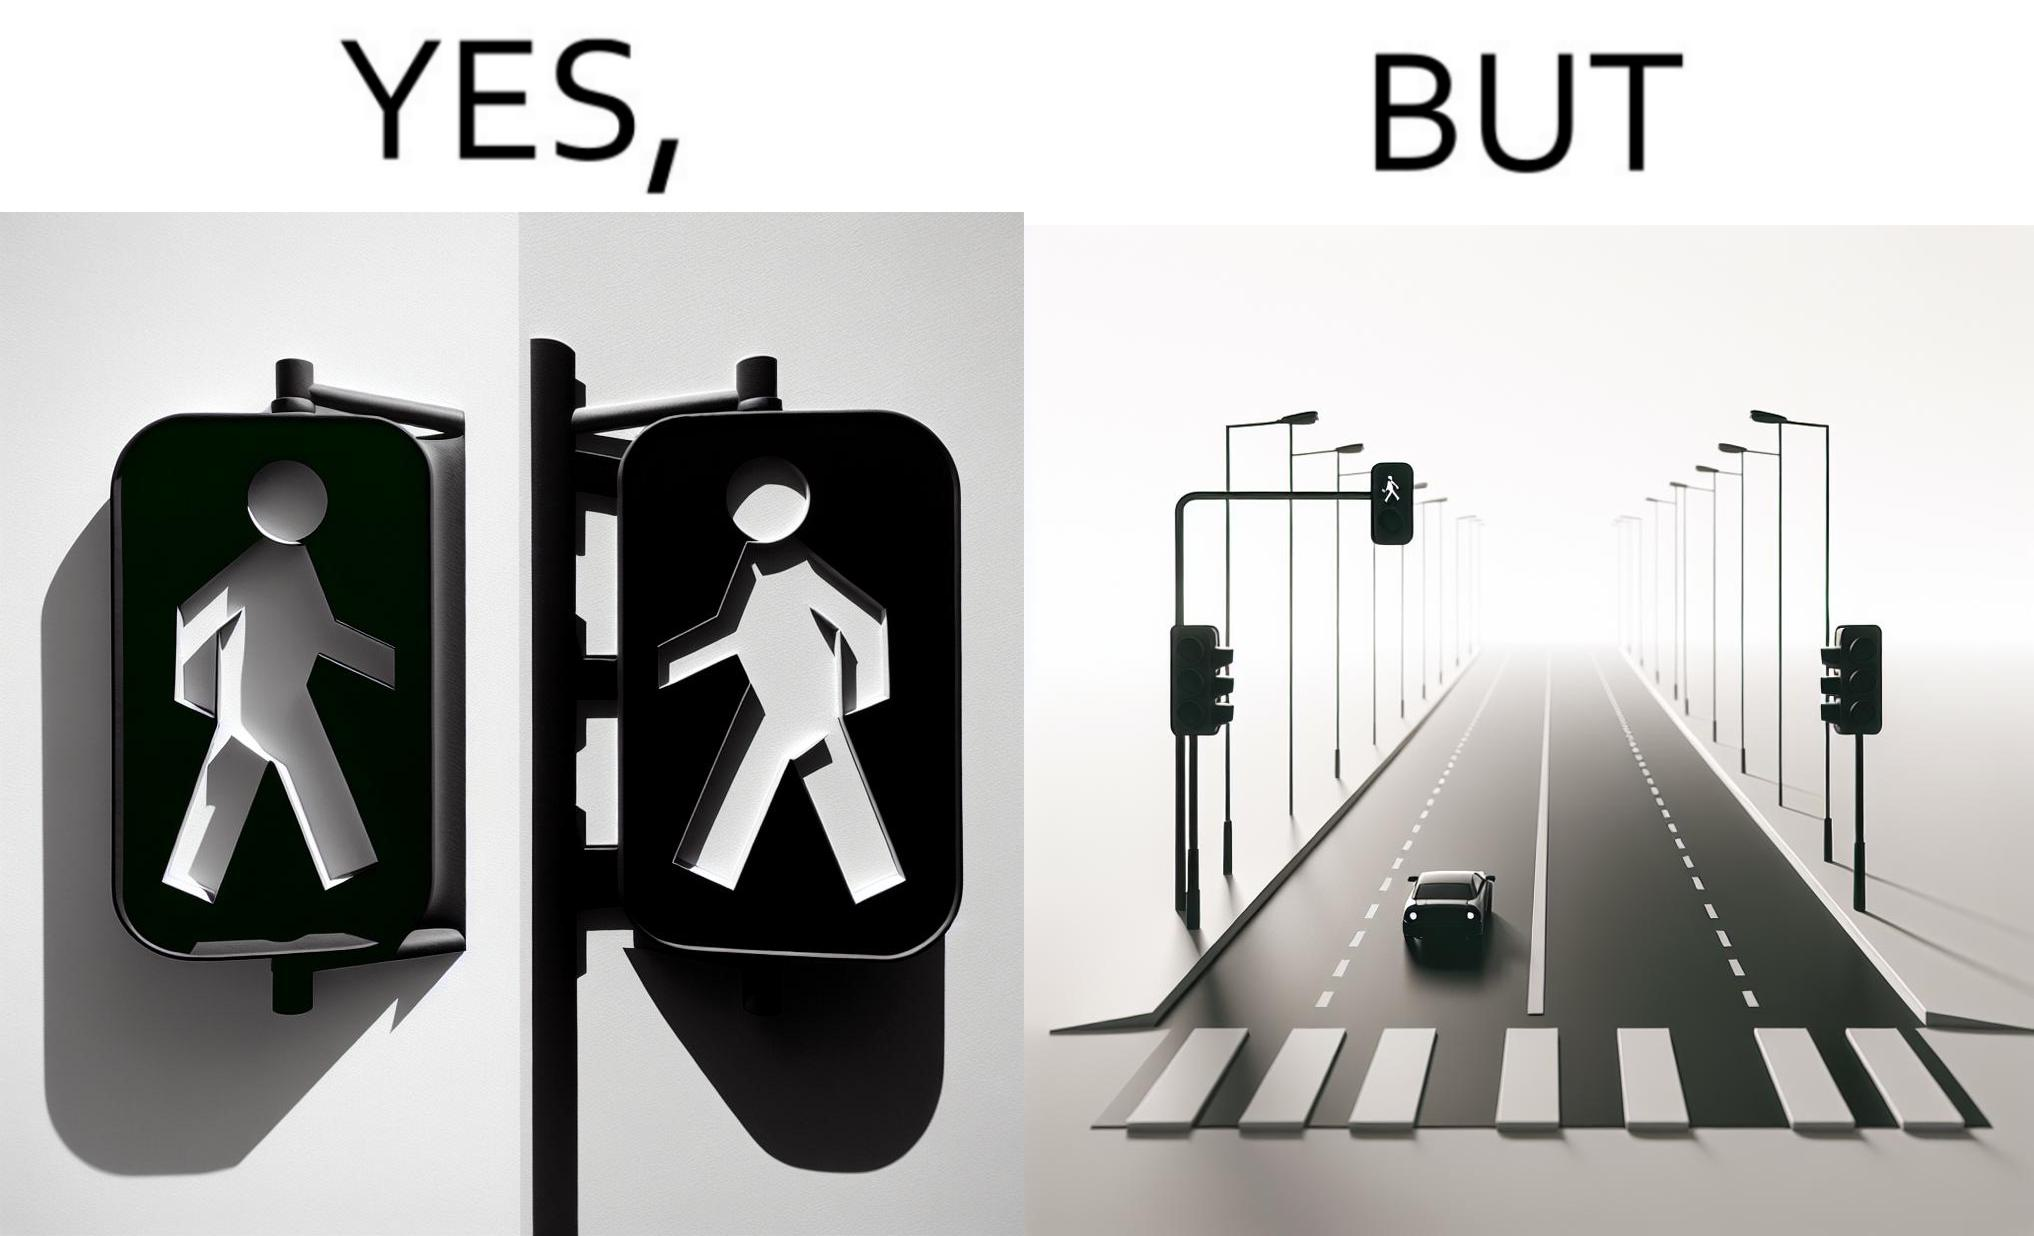Describe the satirical element in this image. The image is funny because while walk signs are very useful for pedestrians to be able to cross roads safely, the become unnecessary and annoying for car drivers when these signals turn green even when there is no pedestrian tring to cross the road. 